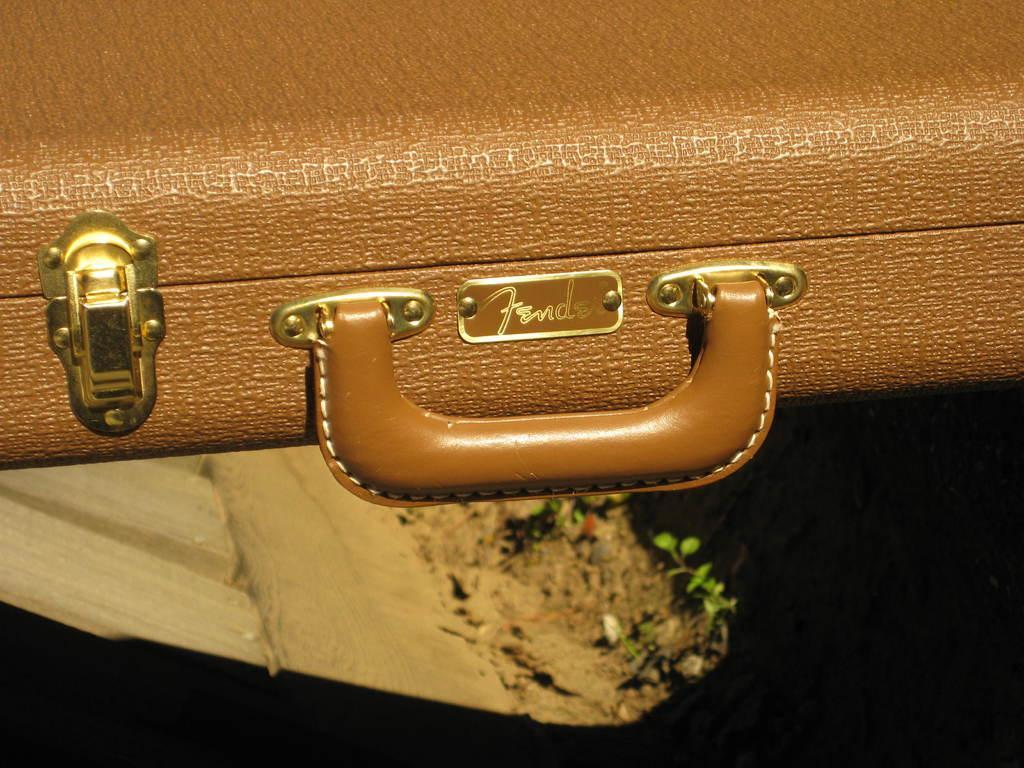How would you summarize this image in a sentence or two? This picture show a briefcase which is brown in colour and we see a clip to it which is golden in colour and buckle in order to hold and we see a name on it 